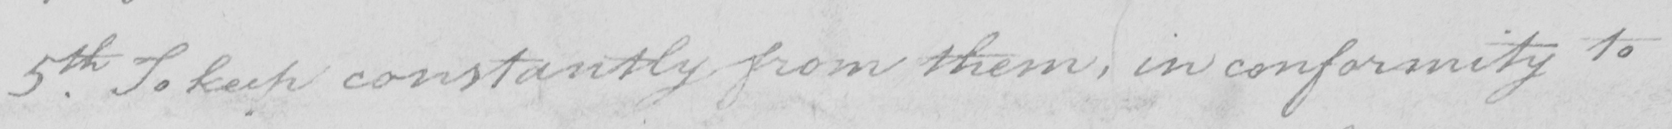Can you tell me what this handwritten text says? 5th . To keep constantly from them , in conformity to 